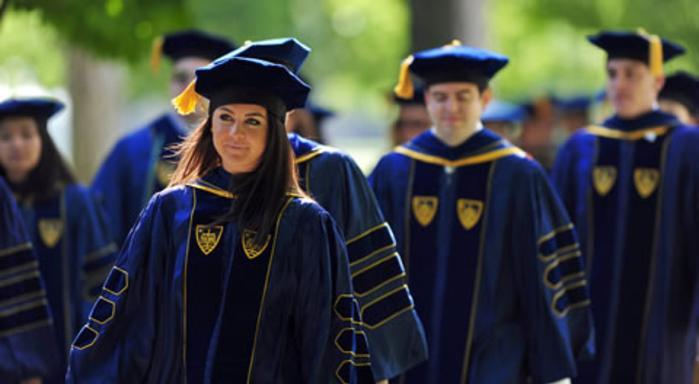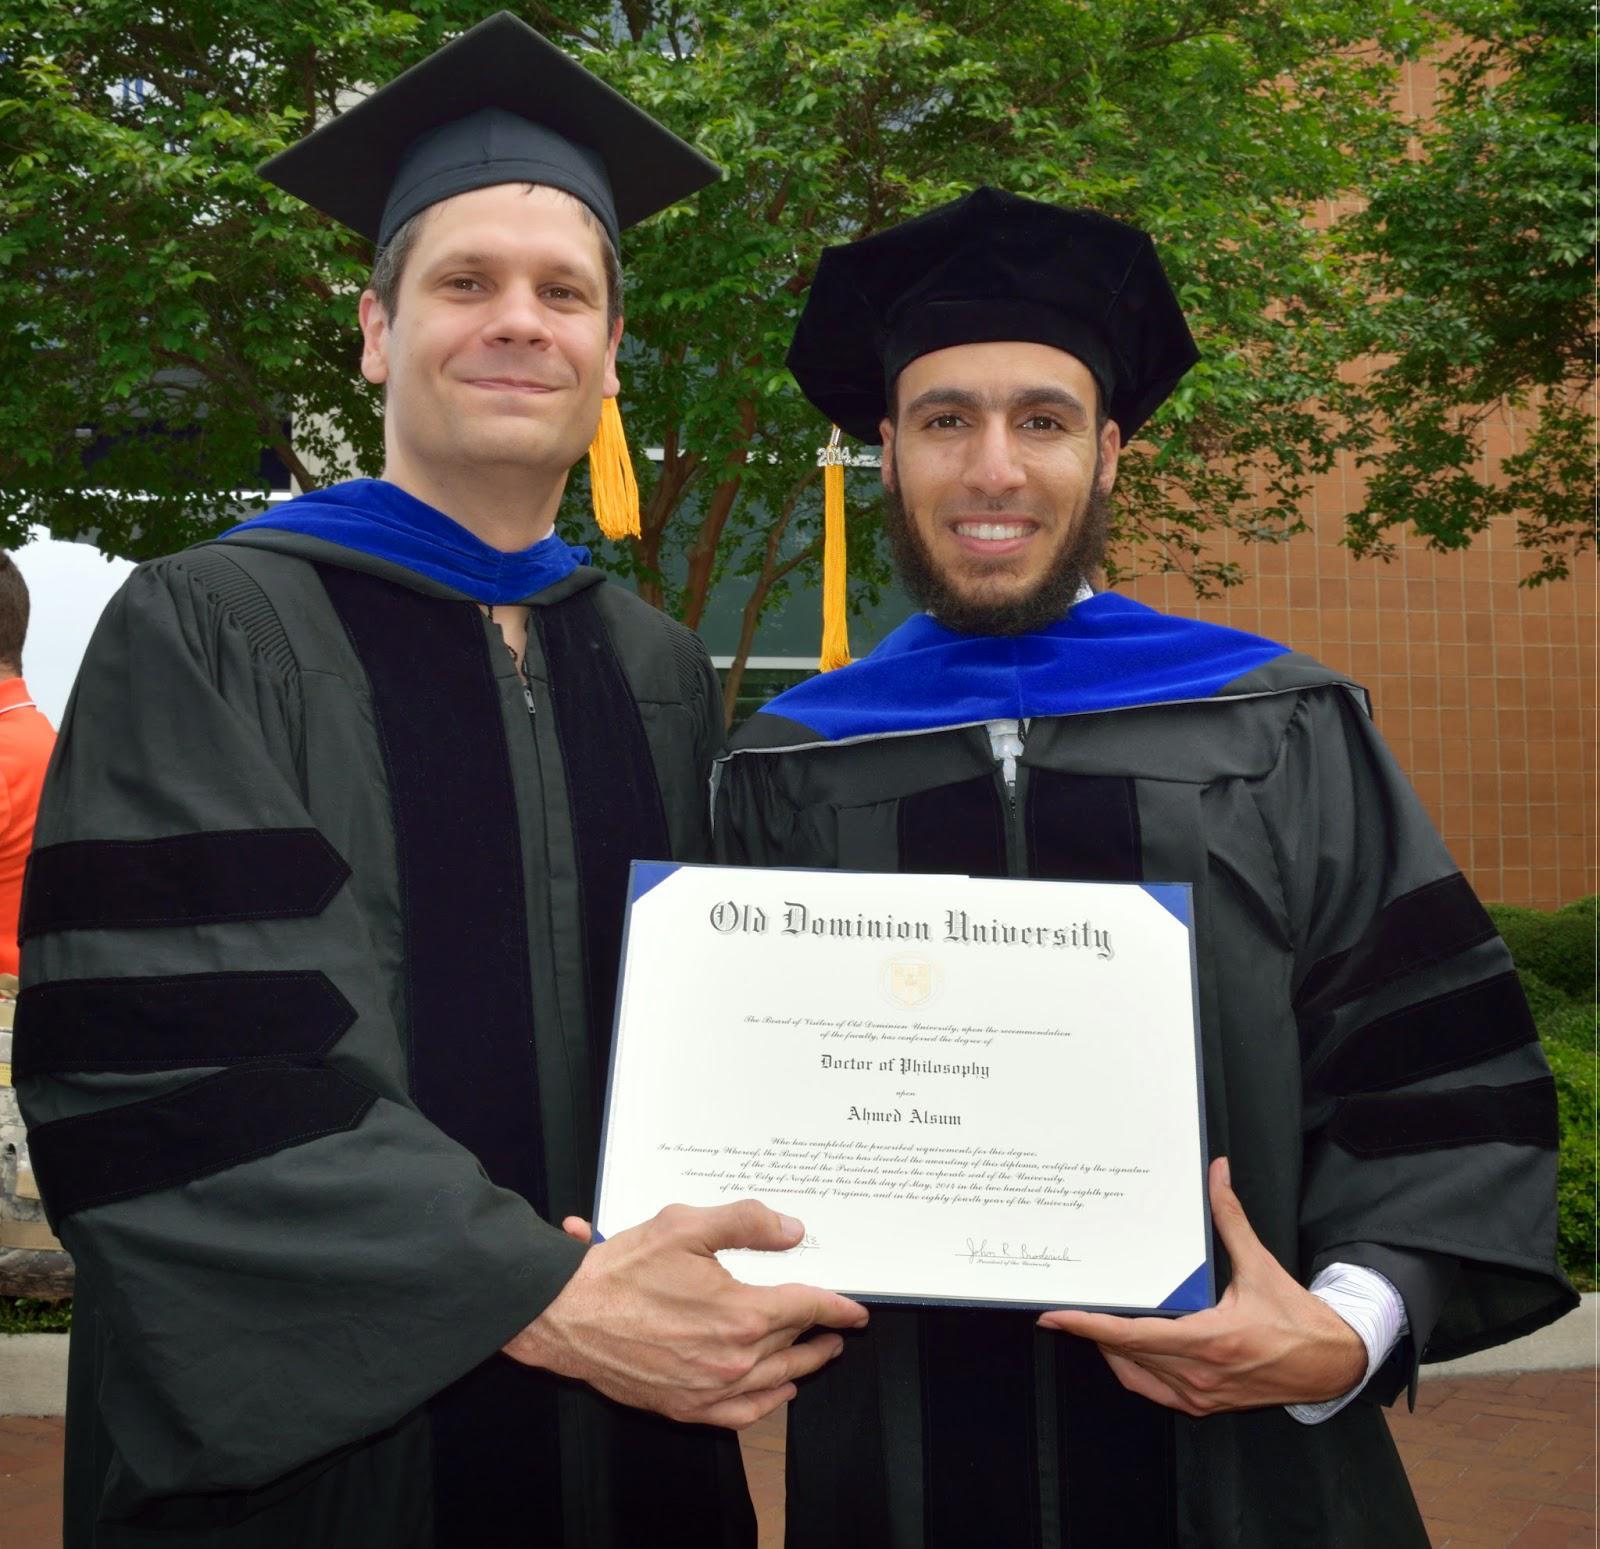The first image is the image on the left, the second image is the image on the right. Considering the images on both sides, is "Two people, a woman and a man, are wearing graduation attire in the image on the right." valid? Answer yes or no. No. The first image is the image on the left, the second image is the image on the right. For the images displayed, is the sentence "An image shows two side-by-side camera-facing graduates who together hold up a single object in front of them." factually correct? Answer yes or no. Yes. 